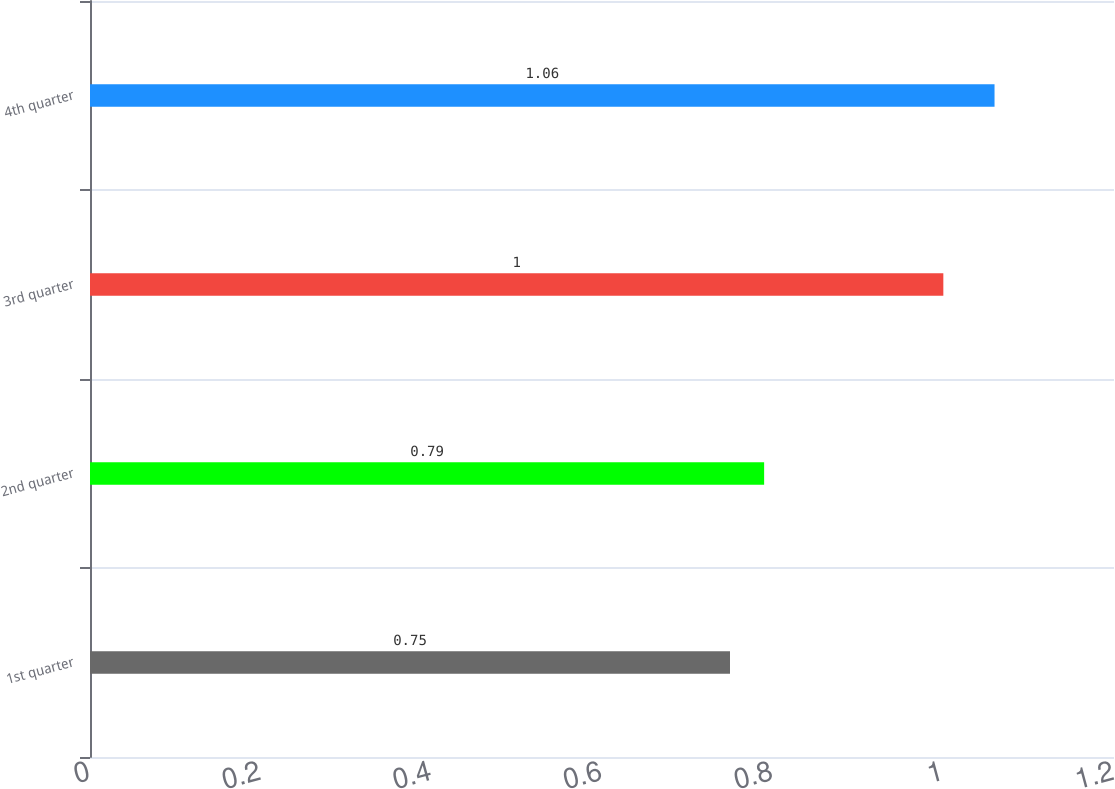Convert chart to OTSL. <chart><loc_0><loc_0><loc_500><loc_500><bar_chart><fcel>1st quarter<fcel>2nd quarter<fcel>3rd quarter<fcel>4th quarter<nl><fcel>0.75<fcel>0.79<fcel>1<fcel>1.06<nl></chart> 